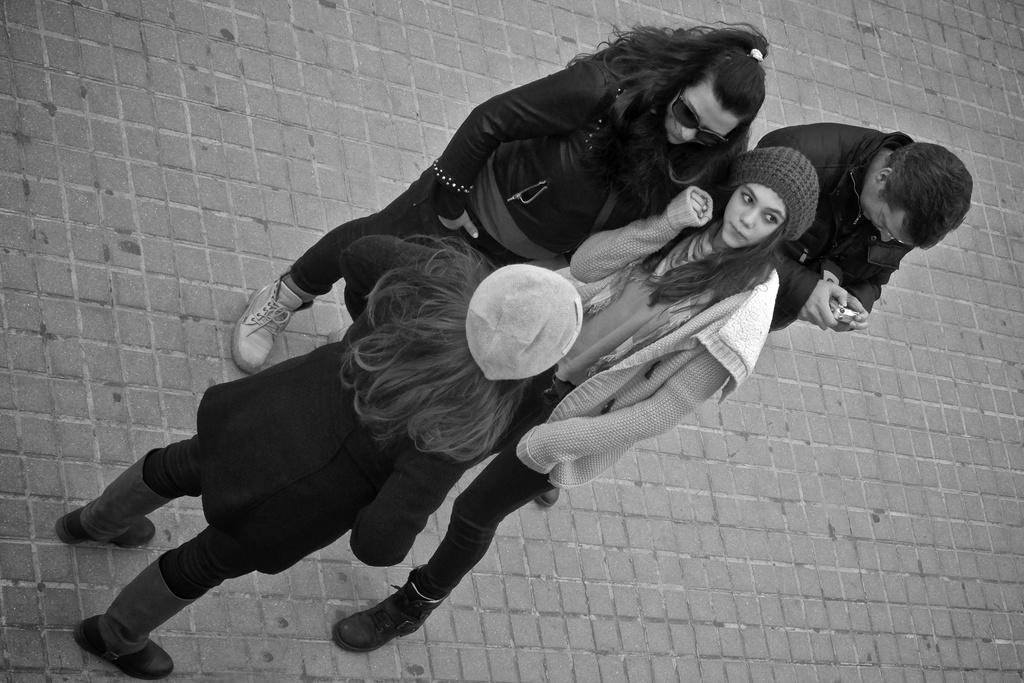Could you give a brief overview of what you see in this image? This is a black and white image. Here I can see four people are wearing jackets and standing on the floor. Three are women and one is man. The man is holding a device in hand and looking at that. 